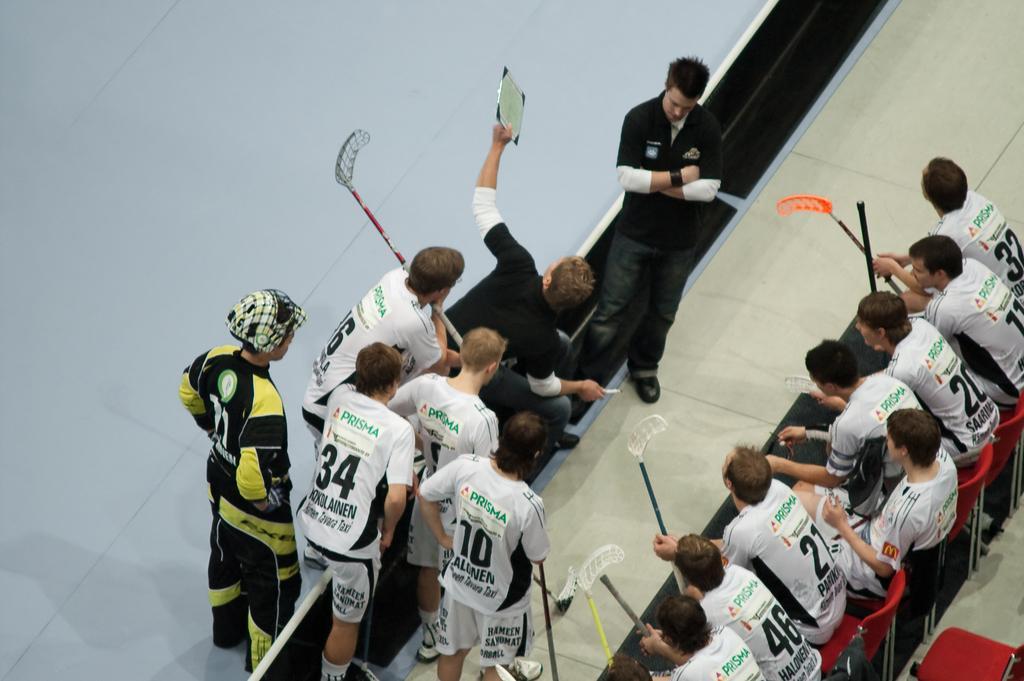In one or two sentences, can you explain what this image depicts? In the image we can see there are people sitting on the chair and others are standing. They are holding sticks in their hand. 